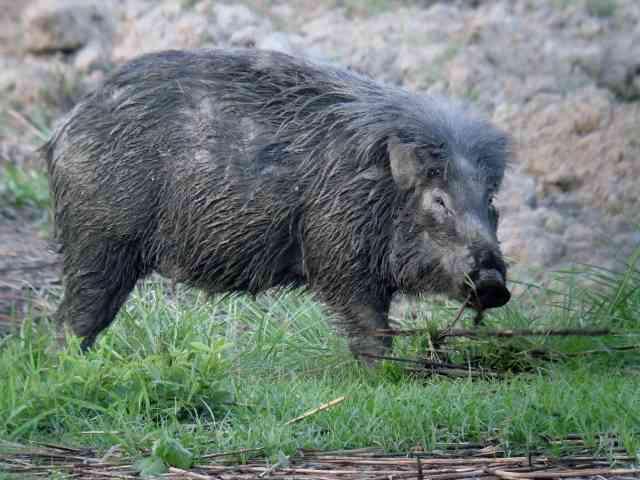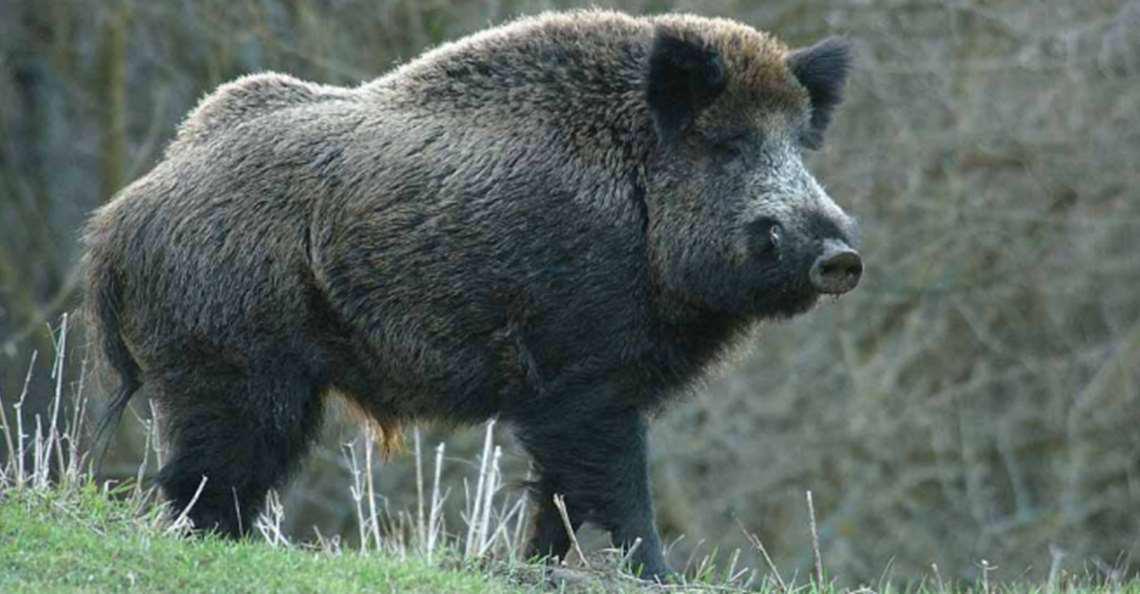The first image is the image on the left, the second image is the image on the right. Analyze the images presented: Is the assertion "The hogs in the pair of images face opposite directions." valid? Answer yes or no. No. 